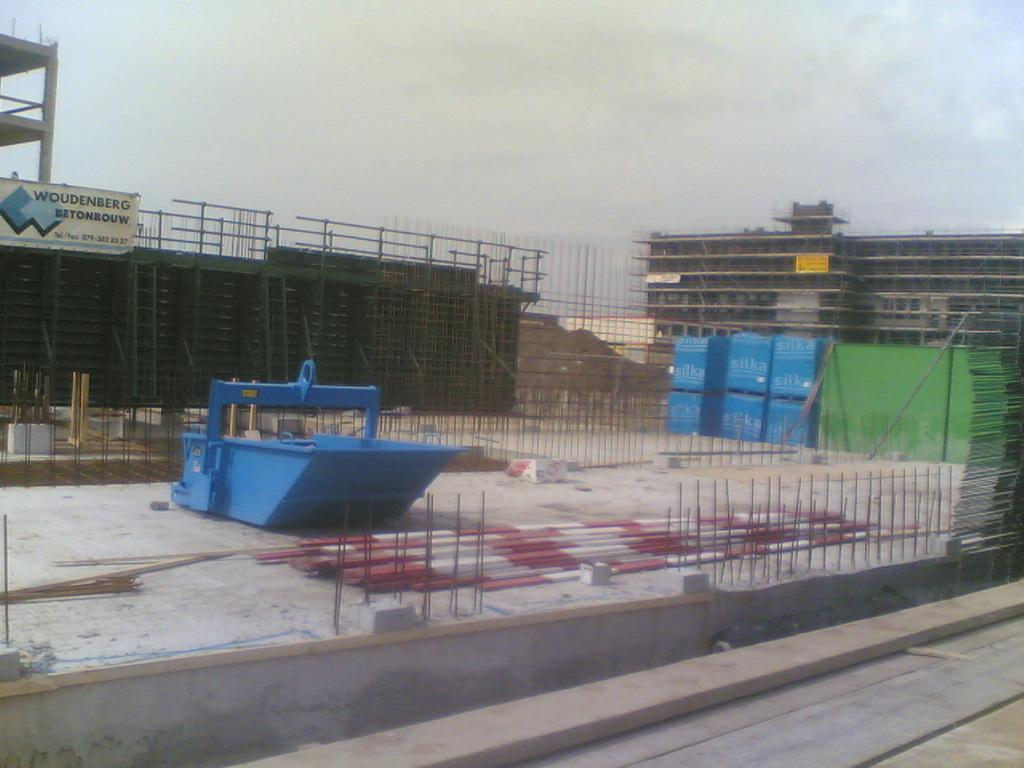What color is the object in the image? The object in the image is blue. What type of material is used for the rods in the image? The rods in the image are made of iron. What can be seen in the background of the image? In the background of the image, there are containers and buildings. What part of the natural environment is visible in the image? The sky is visible in the background of the image. Can you tell me how many wishes are granted on the island in the image? There is no island present in the image, so it is not possible to determine the number of wishes granted. What type of basin is used for washing dishes in the image? There is no basin visible in the image. 